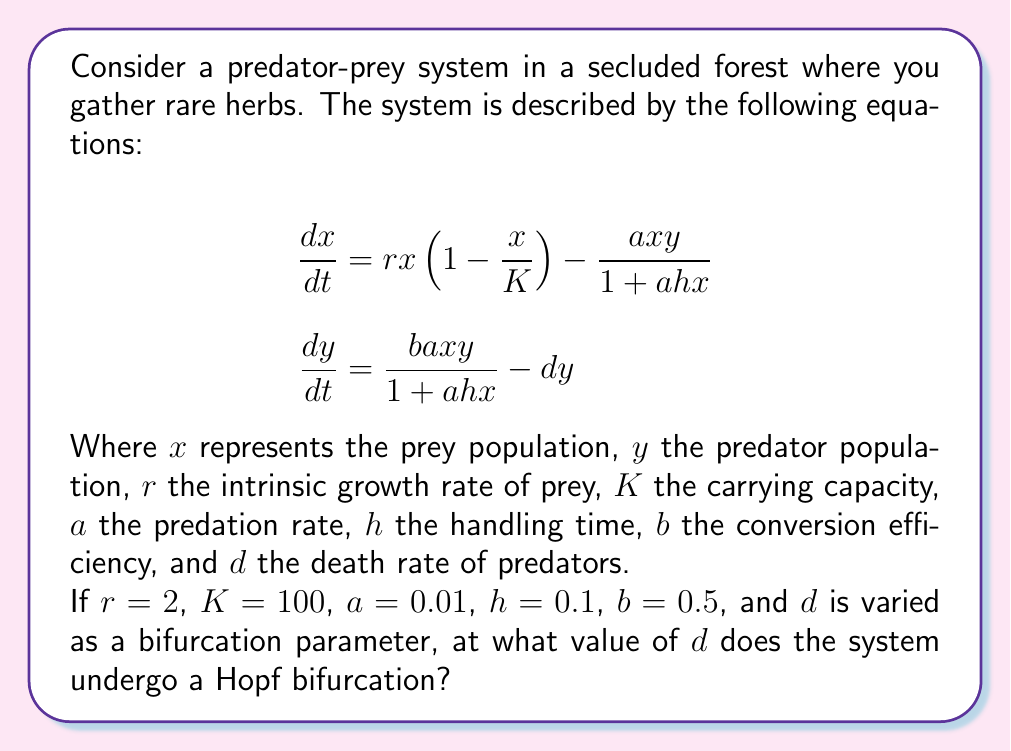Help me with this question. To find the Hopf bifurcation point, we need to follow these steps:

1) Find the non-trivial equilibrium point $(x^*, y^*)$:
   Set $\frac{dx}{dt} = \frac{dy}{dt} = 0$ and solve:

   $$0 = rx^*(1-\frac{x^*}{K}) - \frac{ax^*y^*}{1+ahx^*}$$
   $$0 = \frac{bax^*y^*}{1+ahx^*} - dy^*$$

2) From the second equation:
   $$y^* = \frac{bax^*}{d(1+ahx^*)}$$

3) Substitute this into the first equation:
   $$r(1-\frac{x^*}{K}) = \frac{abx^*}{d(1+ahx^*)}$$

4) Simplify and rearrange:
   $$rx^*(1-\frac{x^*}{K})(1+ahx^*) = \frac{abx^*}{d}$$
   $$r(1-\frac{x^*}{K})(1+ahx^*) = \frac{ab}{d}$$

5) This is a cubic equation in $x^*$. The Hopf bifurcation occurs when the Jacobian matrix at $(x^*, y^*)$ has purely imaginary eigenvalues.

6) The Jacobian matrix is:
   $$J = \begin{bmatrix}
   r(1-\frac{2x^*}{K}) - \frac{ay^*}{(1+ahx^*)^2} & -\frac{ax^*}{1+ahx^*} \\
   \frac{bay^*}{(1+ahx^*)^2} & \frac{bax^*}{1+ahx^*} - d
   \end{bmatrix}$$

7) For a Hopf bifurcation, we need $tr(J) = 0$ and $det(J) > 0$. The trace condition gives:
   $$r(1-\frac{2x^*}{K}) - \frac{ay^*}{(1+ahx^*)^2} + \frac{bax^*}{1+ahx^*} - d = 0$$

8) Substitute the known values and solve this equation along with the equilibrium equation from step 4 numerically.

9) Using numerical methods (e.g., Newton-Raphson), we find that the Hopf bifurcation occurs at approximately:
   $$x^* \approx 33.33, y^* \approx 49.75, d \approx 0.2727$$

Therefore, the system undergoes a Hopf bifurcation when $d \approx 0.2727$.
Answer: 0.2727 